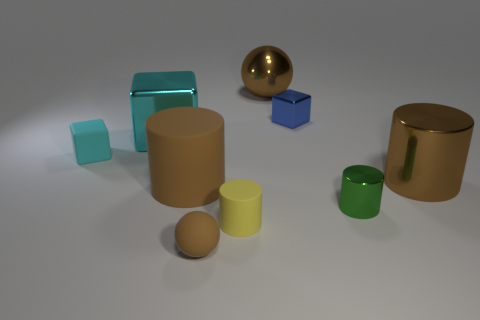Does the large object on the right side of the large metal ball have the same color as the large metallic ball?
Offer a terse response. Yes. What is the material of the tiny object that is the same color as the big rubber thing?
Your response must be concise. Rubber. What is the size of the rubber sphere that is the same color as the big metallic sphere?
Provide a short and direct response. Small. What number of other objects are there of the same shape as the yellow matte thing?
Provide a short and direct response. 3. What material is the big brown object that is in front of the large cylinder that is on the right side of the small blue shiny thing?
Ensure brevity in your answer.  Rubber. What number of matte things are tiny cylinders or red spheres?
Offer a very short reply. 1. There is a brown object behind the large cyan object; is there a small brown matte thing left of it?
Your answer should be compact. Yes. How many objects are either large matte cylinders that are in front of the blue cube or big brown metal things that are behind the cyan rubber thing?
Your answer should be very brief. 2. Is there any other thing of the same color as the big matte cylinder?
Ensure brevity in your answer.  Yes. The small object that is right of the small shiny thing that is behind the tiny cyan block left of the tiny yellow matte cylinder is what color?
Your answer should be very brief. Green. 